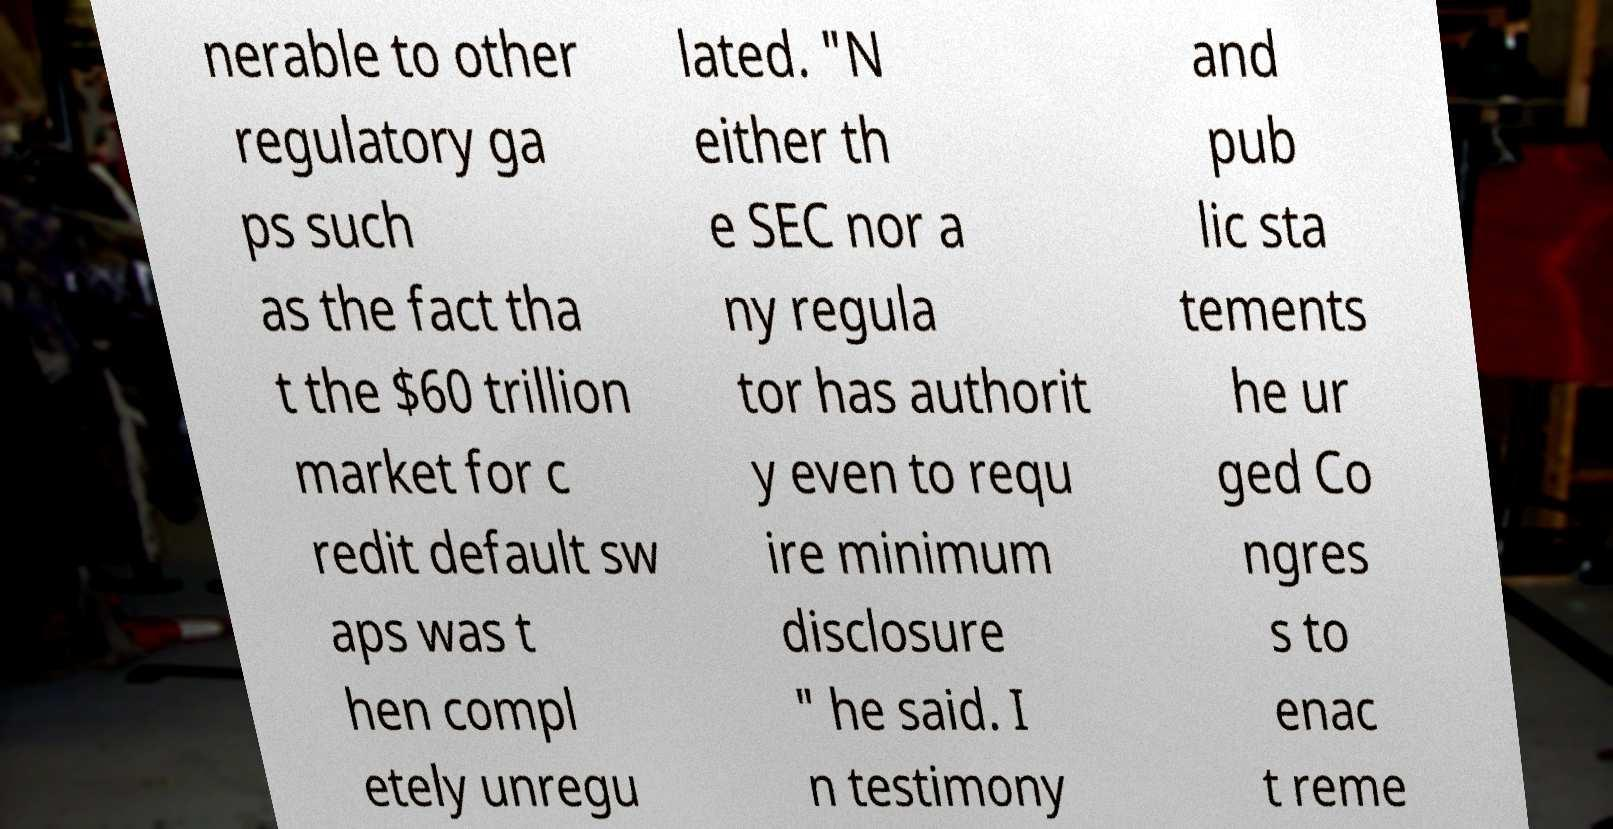Can you accurately transcribe the text from the provided image for me? nerable to other regulatory ga ps such as the fact tha t the $60 trillion market for c redit default sw aps was t hen compl etely unregu lated. "N either th e SEC nor a ny regula tor has authorit y even to requ ire minimum disclosure " he said. I n testimony and pub lic sta tements he ur ged Co ngres s to enac t reme 